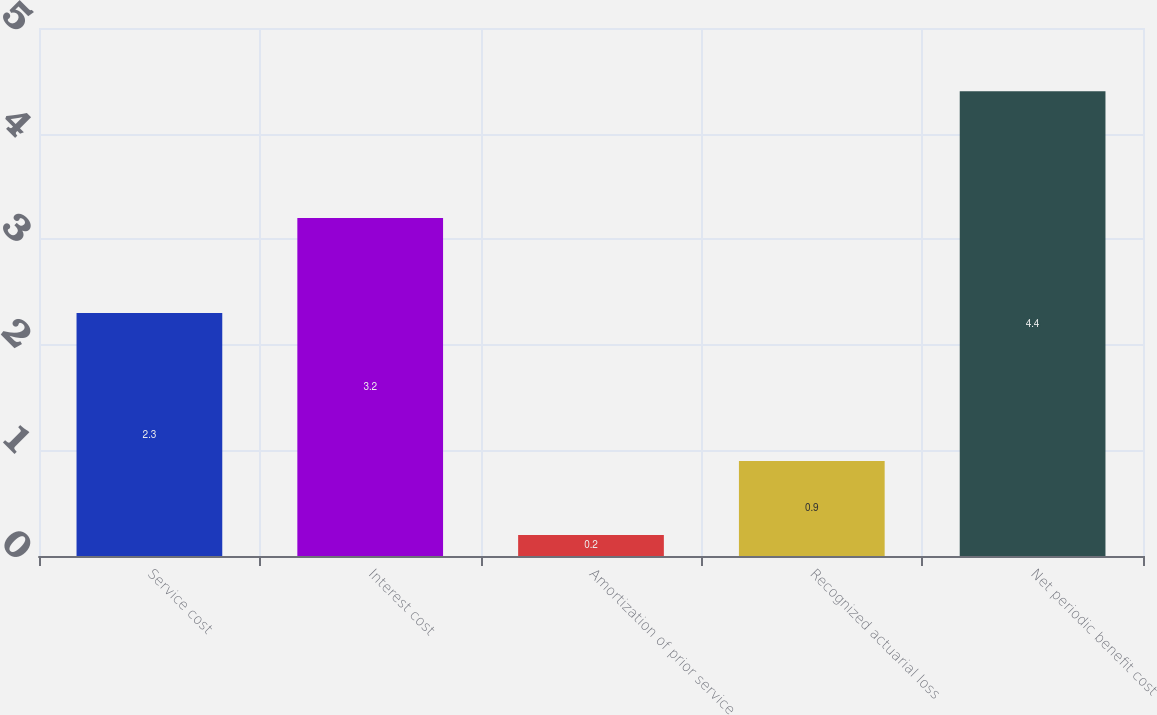Convert chart. <chart><loc_0><loc_0><loc_500><loc_500><bar_chart><fcel>Service cost<fcel>Interest cost<fcel>Amortization of prior service<fcel>Recognized actuarial loss<fcel>Net periodic benefit cost<nl><fcel>2.3<fcel>3.2<fcel>0.2<fcel>0.9<fcel>4.4<nl></chart> 